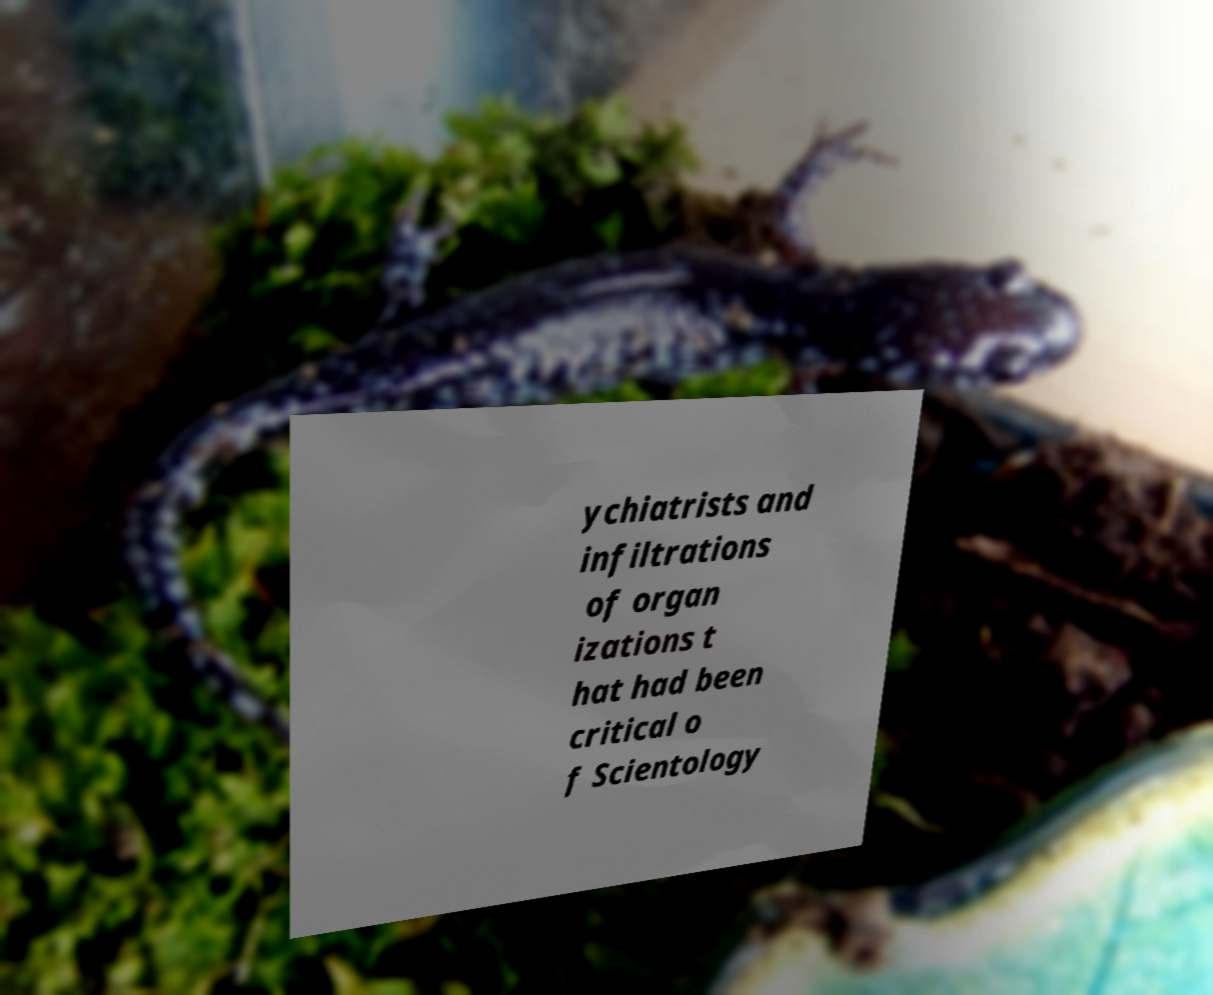Please read and relay the text visible in this image. What does it say? ychiatrists and infiltrations of organ izations t hat had been critical o f Scientology 